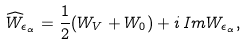Convert formula to latex. <formula><loc_0><loc_0><loc_500><loc_500>\widehat { W } _ { \epsilon _ { \alpha } } = \frac { 1 } { 2 } ( W _ { V } + W _ { 0 } ) + i \, I m W _ { \epsilon _ { \alpha } } ,</formula> 